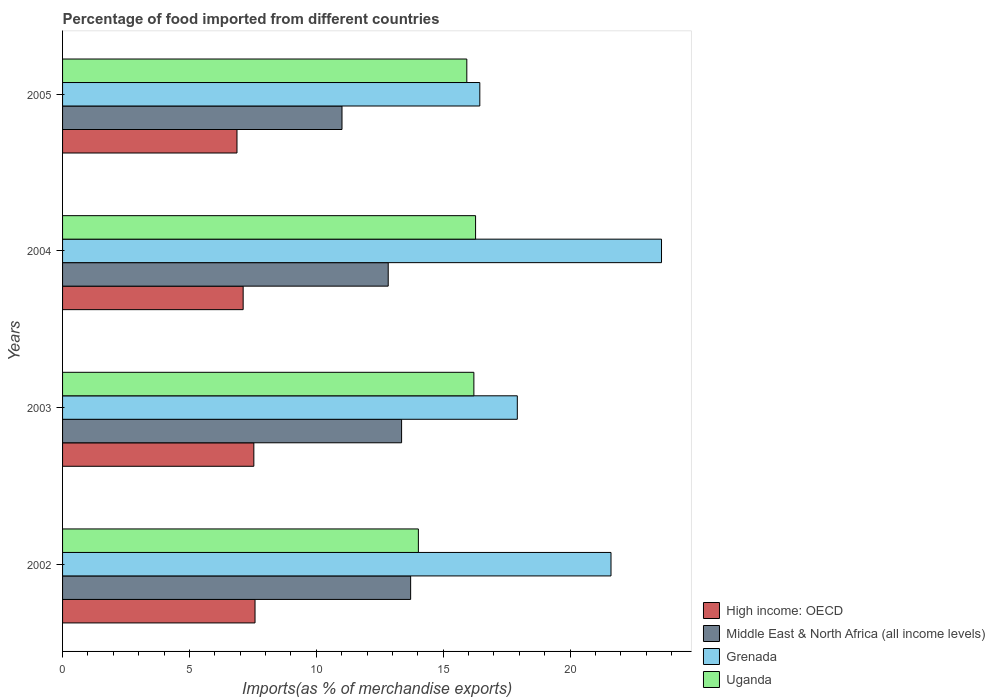Are the number of bars per tick equal to the number of legend labels?
Offer a very short reply. Yes. Are the number of bars on each tick of the Y-axis equal?
Make the answer very short. Yes. How many bars are there on the 4th tick from the top?
Offer a very short reply. 4. How many bars are there on the 4th tick from the bottom?
Your answer should be compact. 4. What is the label of the 3rd group of bars from the top?
Give a very brief answer. 2003. In how many cases, is the number of bars for a given year not equal to the number of legend labels?
Offer a terse response. 0. What is the percentage of imports to different countries in High income: OECD in 2005?
Offer a terse response. 6.87. Across all years, what is the maximum percentage of imports to different countries in Grenada?
Offer a terse response. 23.6. Across all years, what is the minimum percentage of imports to different countries in High income: OECD?
Provide a succinct answer. 6.87. In which year was the percentage of imports to different countries in Uganda minimum?
Keep it short and to the point. 2002. What is the total percentage of imports to different countries in Grenada in the graph?
Your answer should be very brief. 79.58. What is the difference between the percentage of imports to different countries in High income: OECD in 2002 and that in 2004?
Your answer should be compact. 0.47. What is the difference between the percentage of imports to different countries in High income: OECD in 2004 and the percentage of imports to different countries in Grenada in 2002?
Give a very brief answer. -14.5. What is the average percentage of imports to different countries in Grenada per year?
Make the answer very short. 19.9. In the year 2004, what is the difference between the percentage of imports to different countries in Uganda and percentage of imports to different countries in High income: OECD?
Your answer should be compact. 9.16. In how many years, is the percentage of imports to different countries in Uganda greater than 22 %?
Ensure brevity in your answer.  0. What is the ratio of the percentage of imports to different countries in Uganda in 2003 to that in 2005?
Your response must be concise. 1.02. Is the percentage of imports to different countries in Middle East & North Africa (all income levels) in 2004 less than that in 2005?
Provide a short and direct response. No. Is the difference between the percentage of imports to different countries in Uganda in 2002 and 2003 greater than the difference between the percentage of imports to different countries in High income: OECD in 2002 and 2003?
Keep it short and to the point. No. What is the difference between the highest and the second highest percentage of imports to different countries in High income: OECD?
Your answer should be compact. 0.05. What is the difference between the highest and the lowest percentage of imports to different countries in Uganda?
Ensure brevity in your answer.  2.25. In how many years, is the percentage of imports to different countries in High income: OECD greater than the average percentage of imports to different countries in High income: OECD taken over all years?
Your answer should be compact. 2. Is it the case that in every year, the sum of the percentage of imports to different countries in Uganda and percentage of imports to different countries in High income: OECD is greater than the sum of percentage of imports to different countries in Middle East & North Africa (all income levels) and percentage of imports to different countries in Grenada?
Offer a very short reply. Yes. What does the 3rd bar from the top in 2005 represents?
Give a very brief answer. Middle East & North Africa (all income levels). What does the 1st bar from the bottom in 2004 represents?
Your response must be concise. High income: OECD. Is it the case that in every year, the sum of the percentage of imports to different countries in Grenada and percentage of imports to different countries in High income: OECD is greater than the percentage of imports to different countries in Uganda?
Your answer should be very brief. Yes. How many bars are there?
Your answer should be very brief. 16. Are all the bars in the graph horizontal?
Provide a short and direct response. Yes. How many years are there in the graph?
Your response must be concise. 4. What is the difference between two consecutive major ticks on the X-axis?
Give a very brief answer. 5. Does the graph contain any zero values?
Your answer should be compact. No. How are the legend labels stacked?
Give a very brief answer. Vertical. What is the title of the graph?
Keep it short and to the point. Percentage of food imported from different countries. Does "East Asia (developing only)" appear as one of the legend labels in the graph?
Give a very brief answer. No. What is the label or title of the X-axis?
Provide a short and direct response. Imports(as % of merchandise exports). What is the Imports(as % of merchandise exports) of High income: OECD in 2002?
Provide a succinct answer. 7.58. What is the Imports(as % of merchandise exports) in Middle East & North Africa (all income levels) in 2002?
Provide a short and direct response. 13.72. What is the Imports(as % of merchandise exports) in Grenada in 2002?
Keep it short and to the point. 21.61. What is the Imports(as % of merchandise exports) in Uganda in 2002?
Your response must be concise. 14.02. What is the Imports(as % of merchandise exports) in High income: OECD in 2003?
Your answer should be compact. 7.54. What is the Imports(as % of merchandise exports) in Middle East & North Africa (all income levels) in 2003?
Ensure brevity in your answer.  13.36. What is the Imports(as % of merchandise exports) in Grenada in 2003?
Provide a short and direct response. 17.92. What is the Imports(as % of merchandise exports) in Uganda in 2003?
Give a very brief answer. 16.21. What is the Imports(as % of merchandise exports) of High income: OECD in 2004?
Provide a succinct answer. 7.12. What is the Imports(as % of merchandise exports) of Middle East & North Africa (all income levels) in 2004?
Your response must be concise. 12.83. What is the Imports(as % of merchandise exports) in Grenada in 2004?
Give a very brief answer. 23.6. What is the Imports(as % of merchandise exports) of Uganda in 2004?
Give a very brief answer. 16.28. What is the Imports(as % of merchandise exports) of High income: OECD in 2005?
Provide a succinct answer. 6.87. What is the Imports(as % of merchandise exports) of Middle East & North Africa (all income levels) in 2005?
Provide a short and direct response. 11.01. What is the Imports(as % of merchandise exports) in Grenada in 2005?
Provide a short and direct response. 16.44. What is the Imports(as % of merchandise exports) of Uganda in 2005?
Give a very brief answer. 15.93. Across all years, what is the maximum Imports(as % of merchandise exports) of High income: OECD?
Ensure brevity in your answer.  7.58. Across all years, what is the maximum Imports(as % of merchandise exports) of Middle East & North Africa (all income levels)?
Provide a succinct answer. 13.72. Across all years, what is the maximum Imports(as % of merchandise exports) of Grenada?
Offer a very short reply. 23.6. Across all years, what is the maximum Imports(as % of merchandise exports) of Uganda?
Your response must be concise. 16.28. Across all years, what is the minimum Imports(as % of merchandise exports) of High income: OECD?
Give a very brief answer. 6.87. Across all years, what is the minimum Imports(as % of merchandise exports) of Middle East & North Africa (all income levels)?
Make the answer very short. 11.01. Across all years, what is the minimum Imports(as % of merchandise exports) in Grenada?
Your response must be concise. 16.44. Across all years, what is the minimum Imports(as % of merchandise exports) in Uganda?
Provide a succinct answer. 14.02. What is the total Imports(as % of merchandise exports) in High income: OECD in the graph?
Provide a succinct answer. 29.11. What is the total Imports(as % of merchandise exports) of Middle East & North Africa (all income levels) in the graph?
Your answer should be very brief. 50.92. What is the total Imports(as % of merchandise exports) in Grenada in the graph?
Give a very brief answer. 79.58. What is the total Imports(as % of merchandise exports) of Uganda in the graph?
Offer a very short reply. 62.44. What is the difference between the Imports(as % of merchandise exports) of High income: OECD in 2002 and that in 2003?
Give a very brief answer. 0.05. What is the difference between the Imports(as % of merchandise exports) in Middle East & North Africa (all income levels) in 2002 and that in 2003?
Ensure brevity in your answer.  0.36. What is the difference between the Imports(as % of merchandise exports) of Grenada in 2002 and that in 2003?
Keep it short and to the point. 3.69. What is the difference between the Imports(as % of merchandise exports) in Uganda in 2002 and that in 2003?
Ensure brevity in your answer.  -2.19. What is the difference between the Imports(as % of merchandise exports) of High income: OECD in 2002 and that in 2004?
Your answer should be very brief. 0.47. What is the difference between the Imports(as % of merchandise exports) in Middle East & North Africa (all income levels) in 2002 and that in 2004?
Provide a succinct answer. 0.88. What is the difference between the Imports(as % of merchandise exports) of Grenada in 2002 and that in 2004?
Make the answer very short. -1.99. What is the difference between the Imports(as % of merchandise exports) of Uganda in 2002 and that in 2004?
Keep it short and to the point. -2.25. What is the difference between the Imports(as % of merchandise exports) in High income: OECD in 2002 and that in 2005?
Give a very brief answer. 0.71. What is the difference between the Imports(as % of merchandise exports) in Middle East & North Africa (all income levels) in 2002 and that in 2005?
Provide a short and direct response. 2.7. What is the difference between the Imports(as % of merchandise exports) in Grenada in 2002 and that in 2005?
Provide a succinct answer. 5.17. What is the difference between the Imports(as % of merchandise exports) in Uganda in 2002 and that in 2005?
Ensure brevity in your answer.  -1.91. What is the difference between the Imports(as % of merchandise exports) in High income: OECD in 2003 and that in 2004?
Provide a succinct answer. 0.42. What is the difference between the Imports(as % of merchandise exports) of Middle East & North Africa (all income levels) in 2003 and that in 2004?
Make the answer very short. 0.53. What is the difference between the Imports(as % of merchandise exports) of Grenada in 2003 and that in 2004?
Keep it short and to the point. -5.68. What is the difference between the Imports(as % of merchandise exports) in Uganda in 2003 and that in 2004?
Your answer should be very brief. -0.07. What is the difference between the Imports(as % of merchandise exports) in High income: OECD in 2003 and that in 2005?
Offer a very short reply. 0.66. What is the difference between the Imports(as % of merchandise exports) of Middle East & North Africa (all income levels) in 2003 and that in 2005?
Ensure brevity in your answer.  2.35. What is the difference between the Imports(as % of merchandise exports) in Grenada in 2003 and that in 2005?
Ensure brevity in your answer.  1.48. What is the difference between the Imports(as % of merchandise exports) in Uganda in 2003 and that in 2005?
Provide a succinct answer. 0.28. What is the difference between the Imports(as % of merchandise exports) in High income: OECD in 2004 and that in 2005?
Ensure brevity in your answer.  0.24. What is the difference between the Imports(as % of merchandise exports) of Middle East & North Africa (all income levels) in 2004 and that in 2005?
Offer a very short reply. 1.82. What is the difference between the Imports(as % of merchandise exports) in Grenada in 2004 and that in 2005?
Your response must be concise. 7.16. What is the difference between the Imports(as % of merchandise exports) of Uganda in 2004 and that in 2005?
Your answer should be very brief. 0.35. What is the difference between the Imports(as % of merchandise exports) in High income: OECD in 2002 and the Imports(as % of merchandise exports) in Middle East & North Africa (all income levels) in 2003?
Your response must be concise. -5.78. What is the difference between the Imports(as % of merchandise exports) of High income: OECD in 2002 and the Imports(as % of merchandise exports) of Grenada in 2003?
Make the answer very short. -10.34. What is the difference between the Imports(as % of merchandise exports) in High income: OECD in 2002 and the Imports(as % of merchandise exports) in Uganda in 2003?
Provide a succinct answer. -8.62. What is the difference between the Imports(as % of merchandise exports) in Middle East & North Africa (all income levels) in 2002 and the Imports(as % of merchandise exports) in Grenada in 2003?
Provide a short and direct response. -4.2. What is the difference between the Imports(as % of merchandise exports) in Middle East & North Africa (all income levels) in 2002 and the Imports(as % of merchandise exports) in Uganda in 2003?
Make the answer very short. -2.49. What is the difference between the Imports(as % of merchandise exports) of Grenada in 2002 and the Imports(as % of merchandise exports) of Uganda in 2003?
Keep it short and to the point. 5.4. What is the difference between the Imports(as % of merchandise exports) in High income: OECD in 2002 and the Imports(as % of merchandise exports) in Middle East & North Africa (all income levels) in 2004?
Keep it short and to the point. -5.25. What is the difference between the Imports(as % of merchandise exports) of High income: OECD in 2002 and the Imports(as % of merchandise exports) of Grenada in 2004?
Keep it short and to the point. -16.02. What is the difference between the Imports(as % of merchandise exports) in High income: OECD in 2002 and the Imports(as % of merchandise exports) in Uganda in 2004?
Your answer should be compact. -8.69. What is the difference between the Imports(as % of merchandise exports) of Middle East & North Africa (all income levels) in 2002 and the Imports(as % of merchandise exports) of Grenada in 2004?
Provide a short and direct response. -9.89. What is the difference between the Imports(as % of merchandise exports) of Middle East & North Africa (all income levels) in 2002 and the Imports(as % of merchandise exports) of Uganda in 2004?
Offer a terse response. -2.56. What is the difference between the Imports(as % of merchandise exports) in Grenada in 2002 and the Imports(as % of merchandise exports) in Uganda in 2004?
Provide a succinct answer. 5.34. What is the difference between the Imports(as % of merchandise exports) in High income: OECD in 2002 and the Imports(as % of merchandise exports) in Middle East & North Africa (all income levels) in 2005?
Your answer should be very brief. -3.43. What is the difference between the Imports(as % of merchandise exports) of High income: OECD in 2002 and the Imports(as % of merchandise exports) of Grenada in 2005?
Your answer should be compact. -8.86. What is the difference between the Imports(as % of merchandise exports) of High income: OECD in 2002 and the Imports(as % of merchandise exports) of Uganda in 2005?
Make the answer very short. -8.35. What is the difference between the Imports(as % of merchandise exports) in Middle East & North Africa (all income levels) in 2002 and the Imports(as % of merchandise exports) in Grenada in 2005?
Offer a terse response. -2.73. What is the difference between the Imports(as % of merchandise exports) of Middle East & North Africa (all income levels) in 2002 and the Imports(as % of merchandise exports) of Uganda in 2005?
Give a very brief answer. -2.21. What is the difference between the Imports(as % of merchandise exports) of Grenada in 2002 and the Imports(as % of merchandise exports) of Uganda in 2005?
Offer a very short reply. 5.68. What is the difference between the Imports(as % of merchandise exports) of High income: OECD in 2003 and the Imports(as % of merchandise exports) of Middle East & North Africa (all income levels) in 2004?
Ensure brevity in your answer.  -5.3. What is the difference between the Imports(as % of merchandise exports) of High income: OECD in 2003 and the Imports(as % of merchandise exports) of Grenada in 2004?
Offer a terse response. -16.07. What is the difference between the Imports(as % of merchandise exports) in High income: OECD in 2003 and the Imports(as % of merchandise exports) in Uganda in 2004?
Offer a terse response. -8.74. What is the difference between the Imports(as % of merchandise exports) in Middle East & North Africa (all income levels) in 2003 and the Imports(as % of merchandise exports) in Grenada in 2004?
Give a very brief answer. -10.24. What is the difference between the Imports(as % of merchandise exports) of Middle East & North Africa (all income levels) in 2003 and the Imports(as % of merchandise exports) of Uganda in 2004?
Provide a short and direct response. -2.92. What is the difference between the Imports(as % of merchandise exports) of Grenada in 2003 and the Imports(as % of merchandise exports) of Uganda in 2004?
Provide a short and direct response. 1.64. What is the difference between the Imports(as % of merchandise exports) in High income: OECD in 2003 and the Imports(as % of merchandise exports) in Middle East & North Africa (all income levels) in 2005?
Your answer should be very brief. -3.47. What is the difference between the Imports(as % of merchandise exports) of High income: OECD in 2003 and the Imports(as % of merchandise exports) of Grenada in 2005?
Your response must be concise. -8.91. What is the difference between the Imports(as % of merchandise exports) of High income: OECD in 2003 and the Imports(as % of merchandise exports) of Uganda in 2005?
Make the answer very short. -8.39. What is the difference between the Imports(as % of merchandise exports) in Middle East & North Africa (all income levels) in 2003 and the Imports(as % of merchandise exports) in Grenada in 2005?
Ensure brevity in your answer.  -3.08. What is the difference between the Imports(as % of merchandise exports) of Middle East & North Africa (all income levels) in 2003 and the Imports(as % of merchandise exports) of Uganda in 2005?
Offer a very short reply. -2.57. What is the difference between the Imports(as % of merchandise exports) of Grenada in 2003 and the Imports(as % of merchandise exports) of Uganda in 2005?
Your answer should be very brief. 1.99. What is the difference between the Imports(as % of merchandise exports) of High income: OECD in 2004 and the Imports(as % of merchandise exports) of Middle East & North Africa (all income levels) in 2005?
Offer a very short reply. -3.9. What is the difference between the Imports(as % of merchandise exports) of High income: OECD in 2004 and the Imports(as % of merchandise exports) of Grenada in 2005?
Keep it short and to the point. -9.33. What is the difference between the Imports(as % of merchandise exports) of High income: OECD in 2004 and the Imports(as % of merchandise exports) of Uganda in 2005?
Make the answer very short. -8.81. What is the difference between the Imports(as % of merchandise exports) in Middle East & North Africa (all income levels) in 2004 and the Imports(as % of merchandise exports) in Grenada in 2005?
Make the answer very short. -3.61. What is the difference between the Imports(as % of merchandise exports) in Middle East & North Africa (all income levels) in 2004 and the Imports(as % of merchandise exports) in Uganda in 2005?
Provide a short and direct response. -3.1. What is the difference between the Imports(as % of merchandise exports) in Grenada in 2004 and the Imports(as % of merchandise exports) in Uganda in 2005?
Keep it short and to the point. 7.67. What is the average Imports(as % of merchandise exports) of High income: OECD per year?
Your response must be concise. 7.28. What is the average Imports(as % of merchandise exports) in Middle East & North Africa (all income levels) per year?
Keep it short and to the point. 12.73. What is the average Imports(as % of merchandise exports) in Grenada per year?
Offer a very short reply. 19.9. What is the average Imports(as % of merchandise exports) of Uganda per year?
Ensure brevity in your answer.  15.61. In the year 2002, what is the difference between the Imports(as % of merchandise exports) of High income: OECD and Imports(as % of merchandise exports) of Middle East & North Africa (all income levels)?
Your answer should be very brief. -6.13. In the year 2002, what is the difference between the Imports(as % of merchandise exports) of High income: OECD and Imports(as % of merchandise exports) of Grenada?
Your response must be concise. -14.03. In the year 2002, what is the difference between the Imports(as % of merchandise exports) in High income: OECD and Imports(as % of merchandise exports) in Uganda?
Your response must be concise. -6.44. In the year 2002, what is the difference between the Imports(as % of merchandise exports) of Middle East & North Africa (all income levels) and Imports(as % of merchandise exports) of Grenada?
Offer a terse response. -7.9. In the year 2002, what is the difference between the Imports(as % of merchandise exports) in Middle East & North Africa (all income levels) and Imports(as % of merchandise exports) in Uganda?
Offer a very short reply. -0.3. In the year 2002, what is the difference between the Imports(as % of merchandise exports) in Grenada and Imports(as % of merchandise exports) in Uganda?
Provide a succinct answer. 7.59. In the year 2003, what is the difference between the Imports(as % of merchandise exports) of High income: OECD and Imports(as % of merchandise exports) of Middle East & North Africa (all income levels)?
Ensure brevity in your answer.  -5.82. In the year 2003, what is the difference between the Imports(as % of merchandise exports) in High income: OECD and Imports(as % of merchandise exports) in Grenada?
Your answer should be very brief. -10.38. In the year 2003, what is the difference between the Imports(as % of merchandise exports) of High income: OECD and Imports(as % of merchandise exports) of Uganda?
Offer a very short reply. -8.67. In the year 2003, what is the difference between the Imports(as % of merchandise exports) of Middle East & North Africa (all income levels) and Imports(as % of merchandise exports) of Grenada?
Keep it short and to the point. -4.56. In the year 2003, what is the difference between the Imports(as % of merchandise exports) in Middle East & North Africa (all income levels) and Imports(as % of merchandise exports) in Uganda?
Ensure brevity in your answer.  -2.85. In the year 2003, what is the difference between the Imports(as % of merchandise exports) in Grenada and Imports(as % of merchandise exports) in Uganda?
Make the answer very short. 1.71. In the year 2004, what is the difference between the Imports(as % of merchandise exports) in High income: OECD and Imports(as % of merchandise exports) in Middle East & North Africa (all income levels)?
Make the answer very short. -5.72. In the year 2004, what is the difference between the Imports(as % of merchandise exports) of High income: OECD and Imports(as % of merchandise exports) of Grenada?
Provide a short and direct response. -16.49. In the year 2004, what is the difference between the Imports(as % of merchandise exports) in High income: OECD and Imports(as % of merchandise exports) in Uganda?
Offer a terse response. -9.16. In the year 2004, what is the difference between the Imports(as % of merchandise exports) in Middle East & North Africa (all income levels) and Imports(as % of merchandise exports) in Grenada?
Ensure brevity in your answer.  -10.77. In the year 2004, what is the difference between the Imports(as % of merchandise exports) of Middle East & North Africa (all income levels) and Imports(as % of merchandise exports) of Uganda?
Provide a succinct answer. -3.44. In the year 2004, what is the difference between the Imports(as % of merchandise exports) in Grenada and Imports(as % of merchandise exports) in Uganda?
Offer a very short reply. 7.33. In the year 2005, what is the difference between the Imports(as % of merchandise exports) of High income: OECD and Imports(as % of merchandise exports) of Middle East & North Africa (all income levels)?
Your answer should be very brief. -4.14. In the year 2005, what is the difference between the Imports(as % of merchandise exports) of High income: OECD and Imports(as % of merchandise exports) of Grenada?
Make the answer very short. -9.57. In the year 2005, what is the difference between the Imports(as % of merchandise exports) of High income: OECD and Imports(as % of merchandise exports) of Uganda?
Provide a succinct answer. -9.06. In the year 2005, what is the difference between the Imports(as % of merchandise exports) in Middle East & North Africa (all income levels) and Imports(as % of merchandise exports) in Grenada?
Provide a succinct answer. -5.43. In the year 2005, what is the difference between the Imports(as % of merchandise exports) in Middle East & North Africa (all income levels) and Imports(as % of merchandise exports) in Uganda?
Ensure brevity in your answer.  -4.92. In the year 2005, what is the difference between the Imports(as % of merchandise exports) of Grenada and Imports(as % of merchandise exports) of Uganda?
Keep it short and to the point. 0.51. What is the ratio of the Imports(as % of merchandise exports) in Middle East & North Africa (all income levels) in 2002 to that in 2003?
Offer a very short reply. 1.03. What is the ratio of the Imports(as % of merchandise exports) in Grenada in 2002 to that in 2003?
Make the answer very short. 1.21. What is the ratio of the Imports(as % of merchandise exports) of Uganda in 2002 to that in 2003?
Make the answer very short. 0.86. What is the ratio of the Imports(as % of merchandise exports) in High income: OECD in 2002 to that in 2004?
Offer a terse response. 1.07. What is the ratio of the Imports(as % of merchandise exports) in Middle East & North Africa (all income levels) in 2002 to that in 2004?
Make the answer very short. 1.07. What is the ratio of the Imports(as % of merchandise exports) in Grenada in 2002 to that in 2004?
Offer a terse response. 0.92. What is the ratio of the Imports(as % of merchandise exports) in Uganda in 2002 to that in 2004?
Offer a terse response. 0.86. What is the ratio of the Imports(as % of merchandise exports) of High income: OECD in 2002 to that in 2005?
Make the answer very short. 1.1. What is the ratio of the Imports(as % of merchandise exports) in Middle East & North Africa (all income levels) in 2002 to that in 2005?
Your response must be concise. 1.25. What is the ratio of the Imports(as % of merchandise exports) of Grenada in 2002 to that in 2005?
Ensure brevity in your answer.  1.31. What is the ratio of the Imports(as % of merchandise exports) in Uganda in 2002 to that in 2005?
Ensure brevity in your answer.  0.88. What is the ratio of the Imports(as % of merchandise exports) of High income: OECD in 2003 to that in 2004?
Your answer should be compact. 1.06. What is the ratio of the Imports(as % of merchandise exports) of Middle East & North Africa (all income levels) in 2003 to that in 2004?
Give a very brief answer. 1.04. What is the ratio of the Imports(as % of merchandise exports) of Grenada in 2003 to that in 2004?
Give a very brief answer. 0.76. What is the ratio of the Imports(as % of merchandise exports) of Uganda in 2003 to that in 2004?
Provide a short and direct response. 1. What is the ratio of the Imports(as % of merchandise exports) in High income: OECD in 2003 to that in 2005?
Make the answer very short. 1.1. What is the ratio of the Imports(as % of merchandise exports) of Middle East & North Africa (all income levels) in 2003 to that in 2005?
Provide a succinct answer. 1.21. What is the ratio of the Imports(as % of merchandise exports) of Grenada in 2003 to that in 2005?
Your answer should be compact. 1.09. What is the ratio of the Imports(as % of merchandise exports) in Uganda in 2003 to that in 2005?
Provide a succinct answer. 1.02. What is the ratio of the Imports(as % of merchandise exports) of High income: OECD in 2004 to that in 2005?
Make the answer very short. 1.04. What is the ratio of the Imports(as % of merchandise exports) of Middle East & North Africa (all income levels) in 2004 to that in 2005?
Keep it short and to the point. 1.17. What is the ratio of the Imports(as % of merchandise exports) in Grenada in 2004 to that in 2005?
Your answer should be very brief. 1.44. What is the ratio of the Imports(as % of merchandise exports) in Uganda in 2004 to that in 2005?
Offer a very short reply. 1.02. What is the difference between the highest and the second highest Imports(as % of merchandise exports) of High income: OECD?
Your response must be concise. 0.05. What is the difference between the highest and the second highest Imports(as % of merchandise exports) in Middle East & North Africa (all income levels)?
Ensure brevity in your answer.  0.36. What is the difference between the highest and the second highest Imports(as % of merchandise exports) of Grenada?
Your response must be concise. 1.99. What is the difference between the highest and the second highest Imports(as % of merchandise exports) in Uganda?
Your answer should be compact. 0.07. What is the difference between the highest and the lowest Imports(as % of merchandise exports) in High income: OECD?
Your answer should be compact. 0.71. What is the difference between the highest and the lowest Imports(as % of merchandise exports) in Middle East & North Africa (all income levels)?
Give a very brief answer. 2.7. What is the difference between the highest and the lowest Imports(as % of merchandise exports) in Grenada?
Give a very brief answer. 7.16. What is the difference between the highest and the lowest Imports(as % of merchandise exports) of Uganda?
Provide a succinct answer. 2.25. 